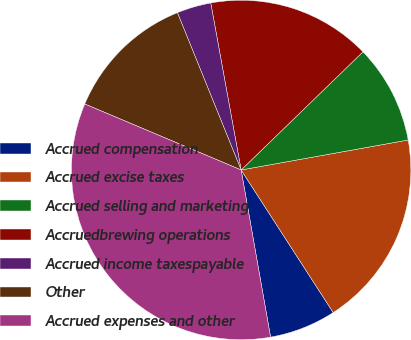<chart> <loc_0><loc_0><loc_500><loc_500><pie_chart><fcel>Accrued compensation<fcel>Accrued excise taxes<fcel>Accrued selling and marketing<fcel>Accruedbrewing operations<fcel>Accrued income taxespayable<fcel>Other<fcel>Accrued expenses and other<nl><fcel>6.35%<fcel>18.7%<fcel>9.43%<fcel>15.61%<fcel>3.26%<fcel>12.52%<fcel>34.13%<nl></chart> 